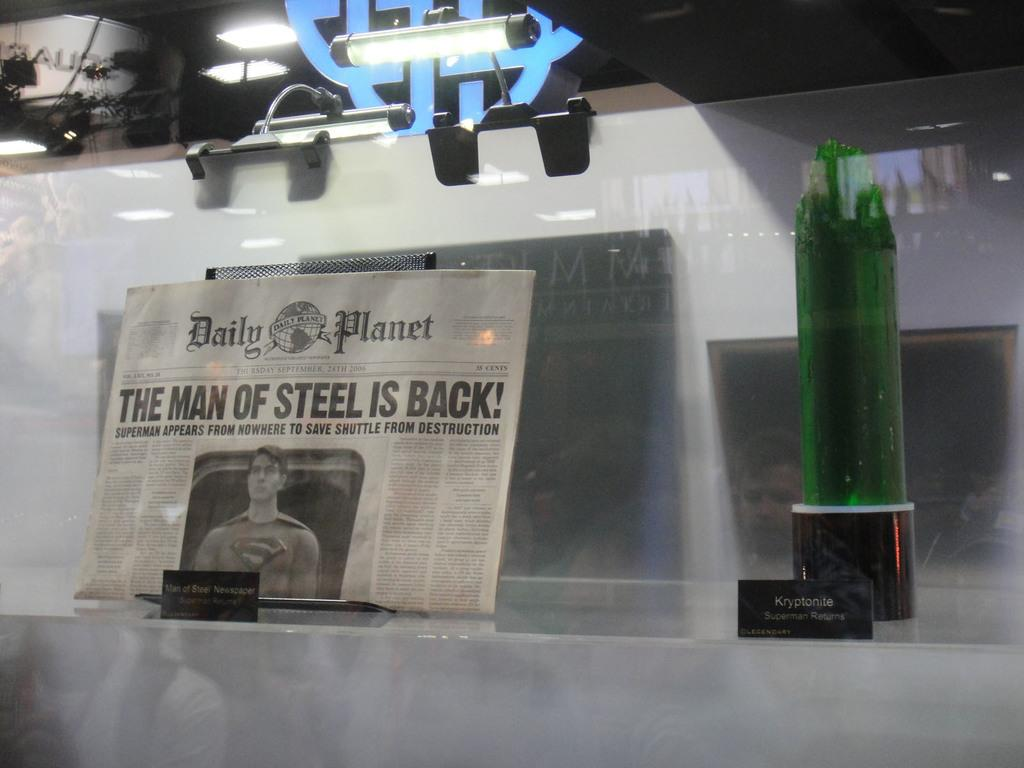<image>
Present a compact description of the photo's key features. On Thursday September, 28th 2006, the Daily Planet released a front page article titled The Man of Steel Is Back! 